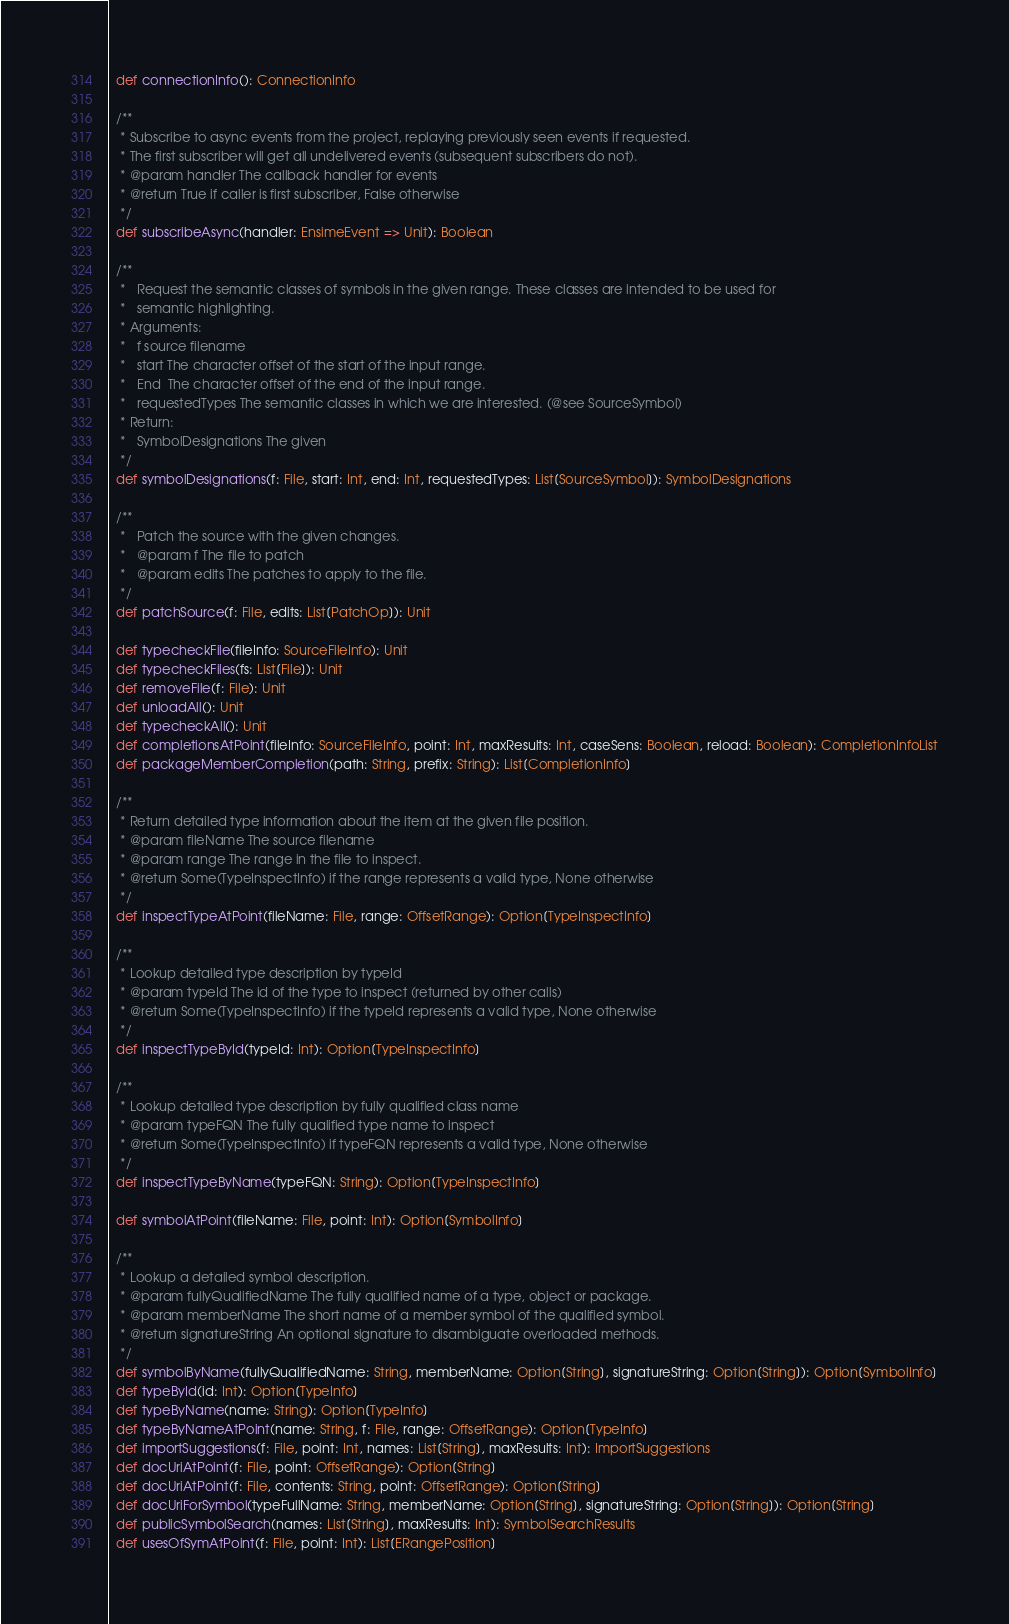Convert code to text. <code><loc_0><loc_0><loc_500><loc_500><_Scala_>
  def connectionInfo(): ConnectionInfo

  /**
   * Subscribe to async events from the project, replaying previously seen events if requested.
   * The first subscriber will get all undelivered events (subsequent subscribers do not).
   * @param handler The callback handler for events
   * @return True if caller is first subscriber, False otherwise
   */
  def subscribeAsync(handler: EnsimeEvent => Unit): Boolean

  /**
   *   Request the semantic classes of symbols in the given range. These classes are intended to be used for
   *   semantic highlighting.
   * Arguments:
   *   f source filename
   *   start The character offset of the start of the input range.
   *   End  The character offset of the end of the input range.
   *   requestedTypes The semantic classes in which we are interested. (@see SourceSymbol)
   * Return:
   *   SymbolDesignations The given
   */
  def symbolDesignations(f: File, start: Int, end: Int, requestedTypes: List[SourceSymbol]): SymbolDesignations

  /**
   *   Patch the source with the given changes.
   *   @param f The file to patch
   *   @param edits The patches to apply to the file.
   */
  def patchSource(f: File, edits: List[PatchOp]): Unit

  def typecheckFile(fileInfo: SourceFileInfo): Unit
  def typecheckFiles(fs: List[File]): Unit
  def removeFile(f: File): Unit
  def unloadAll(): Unit
  def typecheckAll(): Unit
  def completionsAtPoint(fileInfo: SourceFileInfo, point: Int, maxResults: Int, caseSens: Boolean, reload: Boolean): CompletionInfoList
  def packageMemberCompletion(path: String, prefix: String): List[CompletionInfo]

  /**
   * Return detailed type information about the item at the given file position.
   * @param fileName The source filename
   * @param range The range in the file to inspect.
   * @return Some(TypeInspectInfo) if the range represents a valid type, None otherwise
   */
  def inspectTypeAtPoint(fileName: File, range: OffsetRange): Option[TypeInspectInfo]

  /**
   * Lookup detailed type description by typeId
   * @param typeId The id of the type to inspect (returned by other calls)
   * @return Some(TypeInspectInfo) if the typeId represents a valid type, None otherwise
   */
  def inspectTypeById(typeId: Int): Option[TypeInspectInfo]

  /**
   * Lookup detailed type description by fully qualified class name
   * @param typeFQN The fully qualified type name to inspect
   * @return Some(TypeInspectInfo) if typeFQN represents a valid type, None otherwise
   */
  def inspectTypeByName(typeFQN: String): Option[TypeInspectInfo]

  def symbolAtPoint(fileName: File, point: Int): Option[SymbolInfo]

  /**
   * Lookup a detailed symbol description.
   * @param fullyQualifiedName The fully qualified name of a type, object or package.
   * @param memberName The short name of a member symbol of the qualified symbol.
   * @return signatureString An optional signature to disambiguate overloaded methods.
   */
  def symbolByName(fullyQualifiedName: String, memberName: Option[String], signatureString: Option[String]): Option[SymbolInfo]
  def typeById(id: Int): Option[TypeInfo]
  def typeByName(name: String): Option[TypeInfo]
  def typeByNameAtPoint(name: String, f: File, range: OffsetRange): Option[TypeInfo]
  def importSuggestions(f: File, point: Int, names: List[String], maxResults: Int): ImportSuggestions
  def docUriAtPoint(f: File, point: OffsetRange): Option[String]
  def docUriAtPoint(f: File, contents: String, point: OffsetRange): Option[String]
  def docUriForSymbol(typeFullName: String, memberName: Option[String], signatureString: Option[String]): Option[String]
  def publicSymbolSearch(names: List[String], maxResults: Int): SymbolSearchResults
  def usesOfSymAtPoint(f: File, point: Int): List[ERangePosition]</code> 